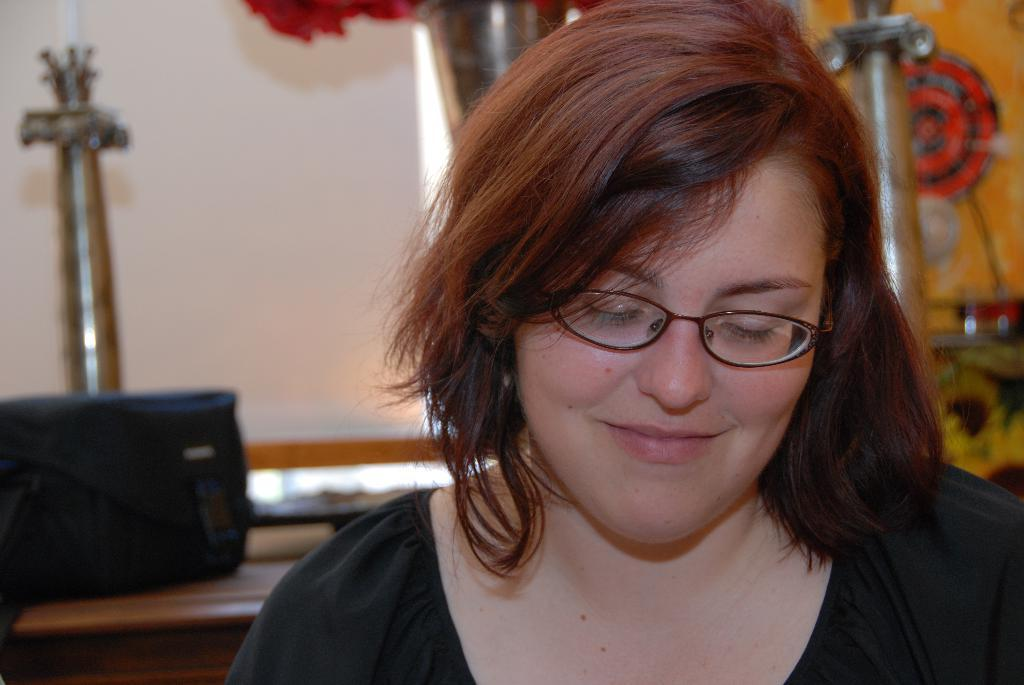What can be seen in the image? There is a person in the image. Can you describe the person's appearance? The person is wearing clothes and spectacles. How would you describe the background of the image? The background of the image is blurred. What type of account does the person have in the cemetery in the image? There is no cemetery present in the image, and therefore no account can be associated with it. 